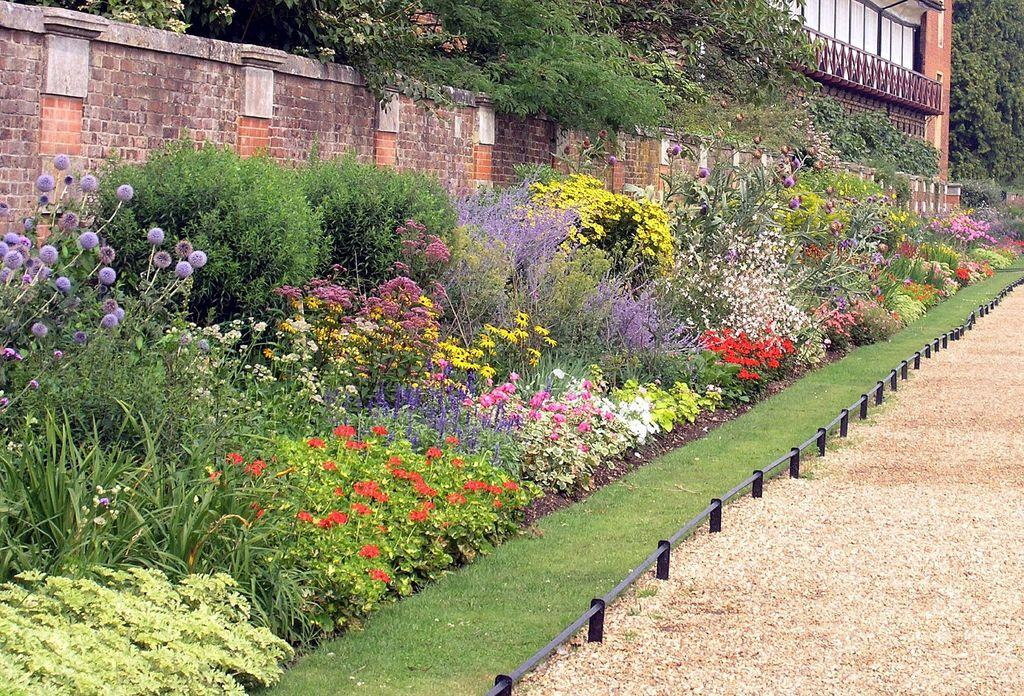What type of surface can be seen in the image? The ground is visible in the image. What type of vegetation is present in the image? There is grass in the image. What type of barrier can be seen in the image? There is a fence in the image. What type of structure can be seen in the image? There is a wall in the image. What type of man-made structure is present in the image? There is a building in the image. What type of plants with colorful features are present in the image? There are plants with flowers in the image. What type of natural elements can be seen in the background of the image? Trees are present in the background of the image. How many birds are sitting on the passenger's shoulder in the image? There are no birds or passengers present in the image. 